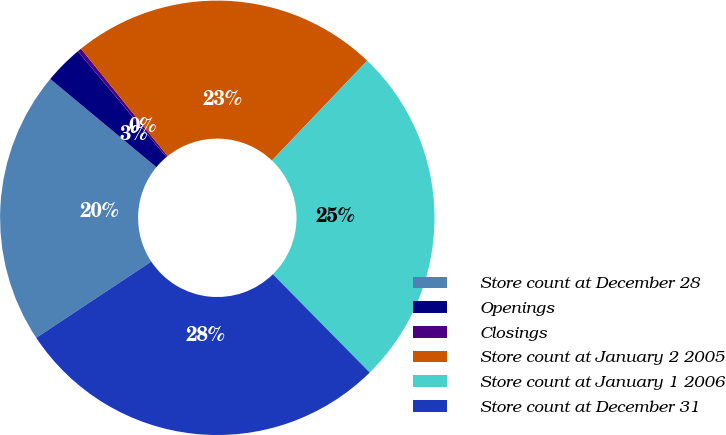Convert chart. <chart><loc_0><loc_0><loc_500><loc_500><pie_chart><fcel>Store count at December 28<fcel>Openings<fcel>Closings<fcel>Store count at January 2 2005<fcel>Store count at January 1 2006<fcel>Store count at December 31<nl><fcel>20.35%<fcel>2.87%<fcel>0.3%<fcel>22.92%<fcel>25.49%<fcel>28.06%<nl></chart> 